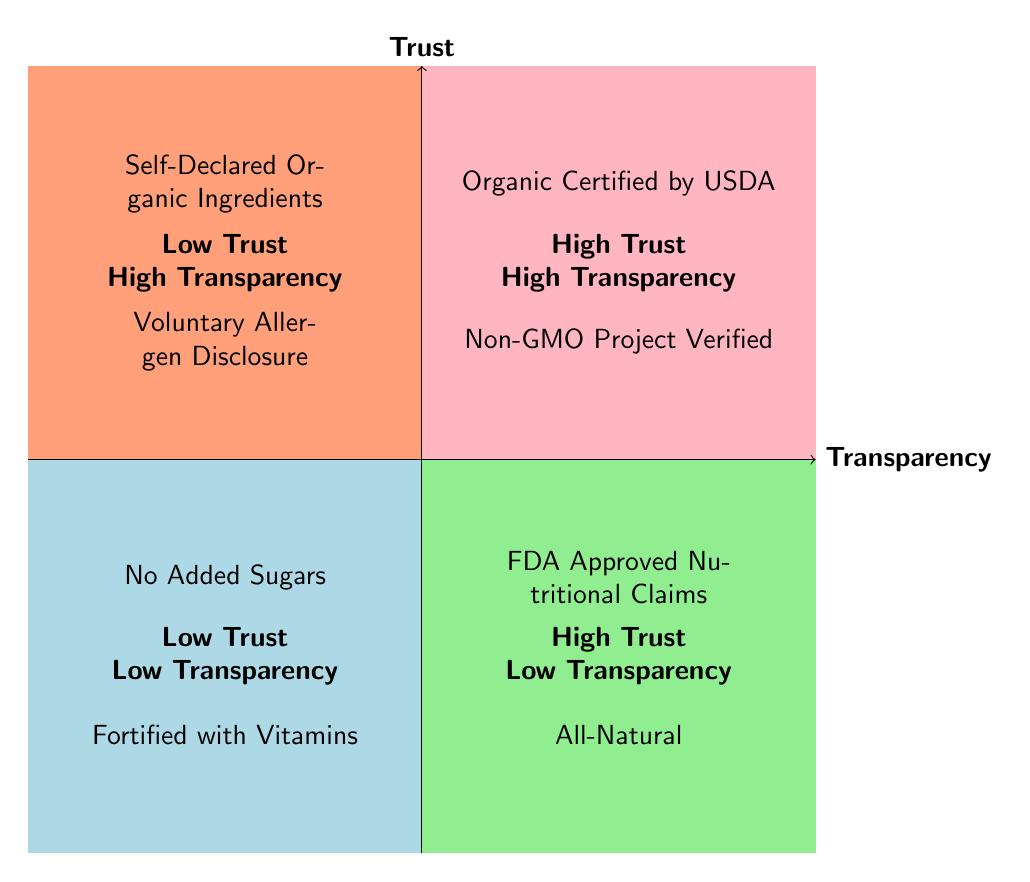What elements are found in the high trust, high transparency quadrant? In the diagram, the high trust, high transparency quadrant contains two elements labeled: "Organic Certified by USDA" and "Non-GMO Project Verified."
Answer: Organic Certified by USDA, Non-GMO Project Verified How many elements are in the low trust, low transparency quadrant? The low trust, low transparency quadrant has two elements: "No Added Sugars" and "Fortified with Vitamins." Thus, there are a total of two elements in this quadrant.
Answer: 2 What element shows high trust but low transparency? In the high trust but low transparency quadrant, the elements listed are "FDA Approved Nutritional Claims" and "All-Natural." Selecting either of these responses will yield an answer that fits the question.
Answer: FDA Approved Nutritional Claims, All-Natural Which quadrant contains self-declared organic ingredients? The element "Self-Declared Organic Ingredients" is located in the low trust, high transparency quadrant, as indicated by its positioning in the diagram.
Answer: Low Trust High Transparency What can be inferred about products labeled as "All-Natural"? The presence of "All-Natural" in the high trust, low transparency quadrant suggests that while consumers may generally trust this label, there is a lack of clarity or detailed information about the item.
Answer: High Trust Low Transparency Which category contains elements that enhance consumer trust through transparency? The high trust, high transparency quadrant contains elements like "Organic Certified by USDA" and "Non-GMO Project Verified," which are trusted because they provide verifiable labels or certifications.
Answer: High Trust High Transparency 